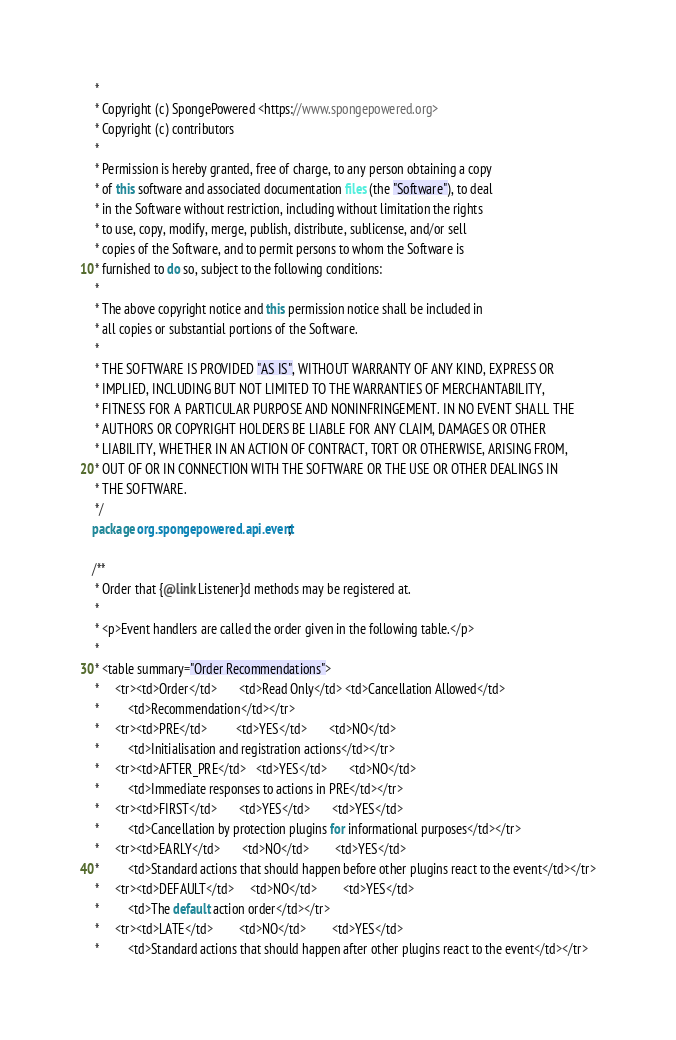Convert code to text. <code><loc_0><loc_0><loc_500><loc_500><_Java_> *
 * Copyright (c) SpongePowered <https://www.spongepowered.org>
 * Copyright (c) contributors
 *
 * Permission is hereby granted, free of charge, to any person obtaining a copy
 * of this software and associated documentation files (the "Software"), to deal
 * in the Software without restriction, including without limitation the rights
 * to use, copy, modify, merge, publish, distribute, sublicense, and/or sell
 * copies of the Software, and to permit persons to whom the Software is
 * furnished to do so, subject to the following conditions:
 *
 * The above copyright notice and this permission notice shall be included in
 * all copies or substantial portions of the Software.
 *
 * THE SOFTWARE IS PROVIDED "AS IS", WITHOUT WARRANTY OF ANY KIND, EXPRESS OR
 * IMPLIED, INCLUDING BUT NOT LIMITED TO THE WARRANTIES OF MERCHANTABILITY,
 * FITNESS FOR A PARTICULAR PURPOSE AND NONINFRINGEMENT. IN NO EVENT SHALL THE
 * AUTHORS OR COPYRIGHT HOLDERS BE LIABLE FOR ANY CLAIM, DAMAGES OR OTHER
 * LIABILITY, WHETHER IN AN ACTION OF CONTRACT, TORT OR OTHERWISE, ARISING FROM,
 * OUT OF OR IN CONNECTION WITH THE SOFTWARE OR THE USE OR OTHER DEALINGS IN
 * THE SOFTWARE.
 */
package org.spongepowered.api.event;

/**
 * Order that {@link Listener}d methods may be registered at.
 *
 * <p>Event handlers are called the order given in the following table.</p>
 *
 * <table summary="Order Recommendations">
 *     <tr><td>Order</td>       <td>Read Only</td> <td>Cancellation Allowed</td>
 *         <td>Recommendation</td></tr>
 *     <tr><td>PRE</td>         <td>YES</td>       <td>NO</td>
 *         <td>Initialisation and registration actions</td></tr>
 *     <tr><td>AFTER_PRE</td>   <td>YES</td>       <td>NO</td>
 *         <td>Immediate responses to actions in PRE</td></tr>
 *     <tr><td>FIRST</td>       <td>YES</td>       <td>YES</td>
 *         <td>Cancellation by protection plugins for informational purposes</td></tr>
 *     <tr><td>EARLY</td>       <td>NO</td>        <td>YES</td>
 *         <td>Standard actions that should happen before other plugins react to the event</td></tr>
 *     <tr><td>DEFAULT</td>     <td>NO</td>        <td>YES</td>
 *         <td>The default action order</td></tr>
 *     <tr><td>LATE</td>        <td>NO</td>        <td>YES</td>
 *         <td>Standard actions that should happen after other plugins react to the event</td></tr></code> 